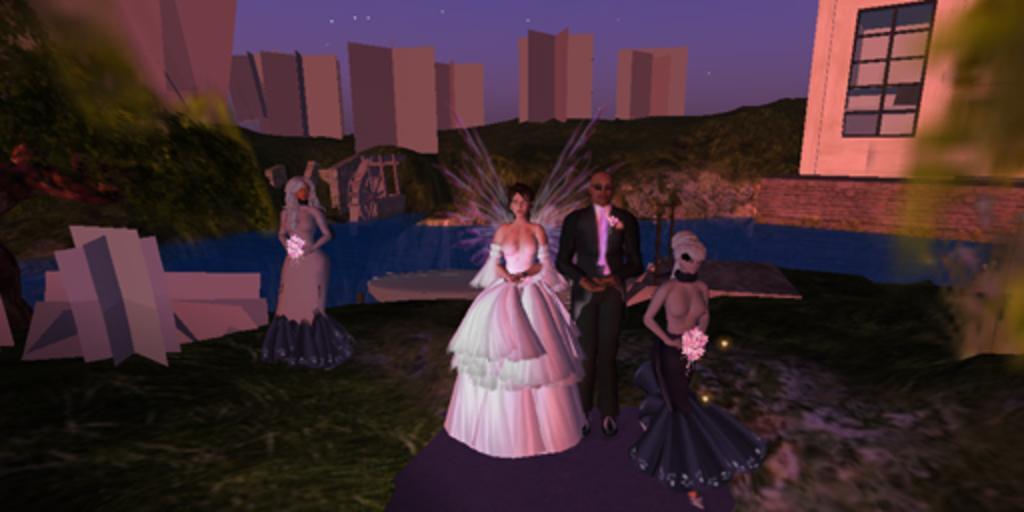Please provide a concise description of this image. It is a graphical image, in the image we can see some persons standing and holding some flower vases. 